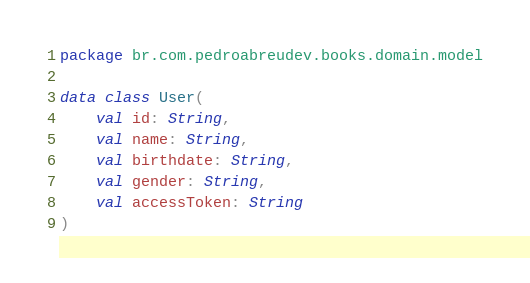Convert code to text. <code><loc_0><loc_0><loc_500><loc_500><_Kotlin_>package br.com.pedroabreudev.books.domain.model

data class User(
    val id: String,
    val name: String,
    val birthdate: String,
    val gender: String,
    val accessToken: String
)
</code> 